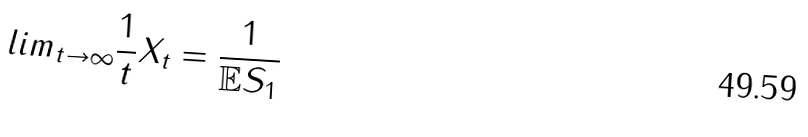<formula> <loc_0><loc_0><loc_500><loc_500>l i m _ { t \rightarrow \infty } \frac { 1 } { t } X _ { t } = \frac { 1 } { \mathbb { E } S _ { 1 } }</formula> 